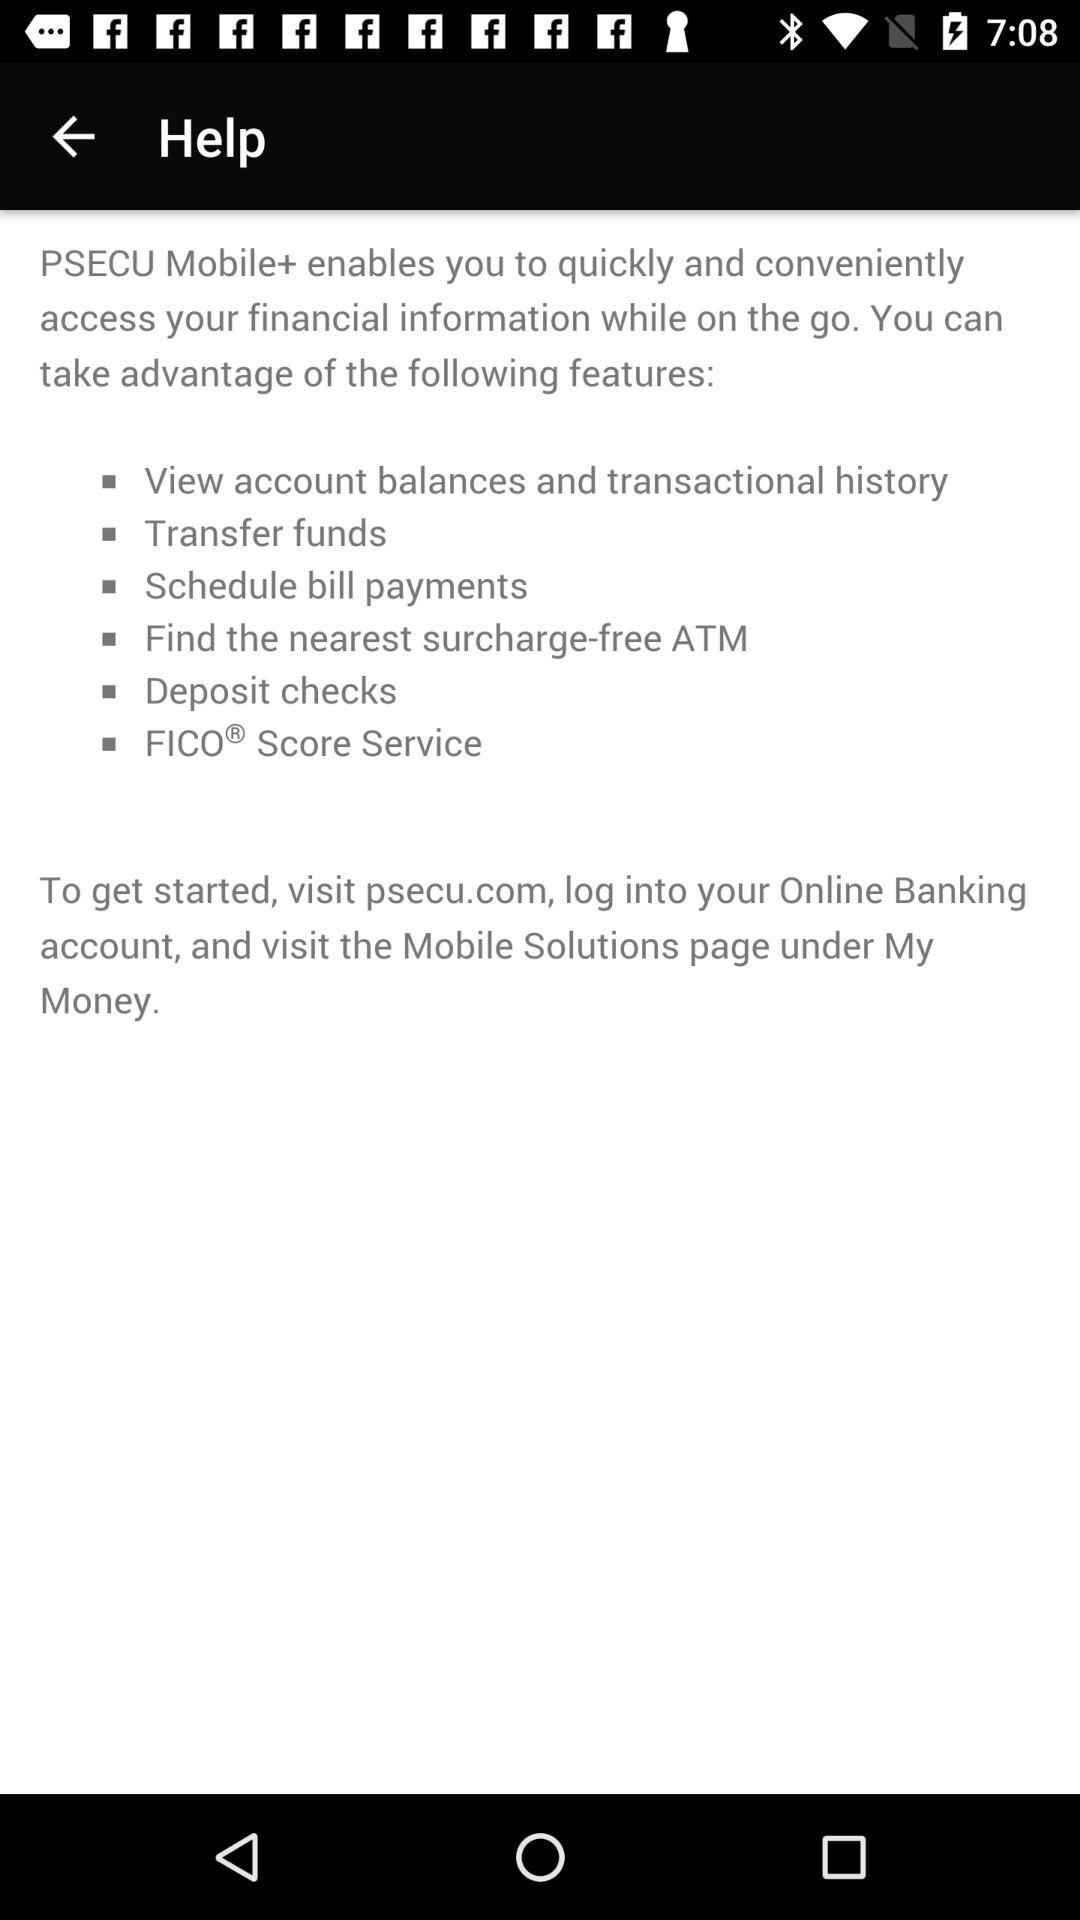What are the features available in "PSECU Mobile+"? The features available are "View account balances and transactional history", "Transfer funds", "Schedule bill payments", "Find the nearest surcharge-free ATM", "Deposit checks" and "IFICO Score Service". 